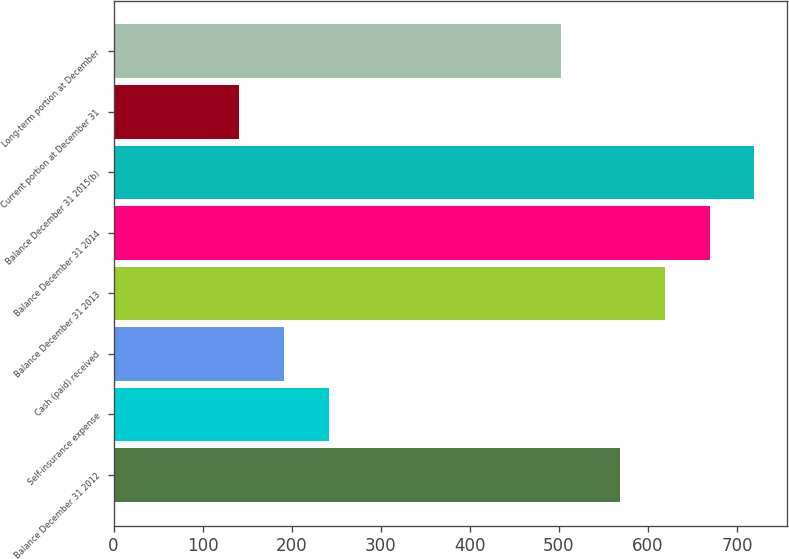Convert chart to OTSL. <chart><loc_0><loc_0><loc_500><loc_500><bar_chart><fcel>Balance December 31 2012<fcel>Self-insurance expense<fcel>Cash (paid) received<fcel>Balance December 31 2013<fcel>Balance December 31 2014<fcel>Balance December 31 2015(b)<fcel>Current portion at December 31<fcel>Long-term portion at December<nl><fcel>569<fcel>241.4<fcel>191.2<fcel>619.2<fcel>669.4<fcel>719.6<fcel>141<fcel>502<nl></chart> 